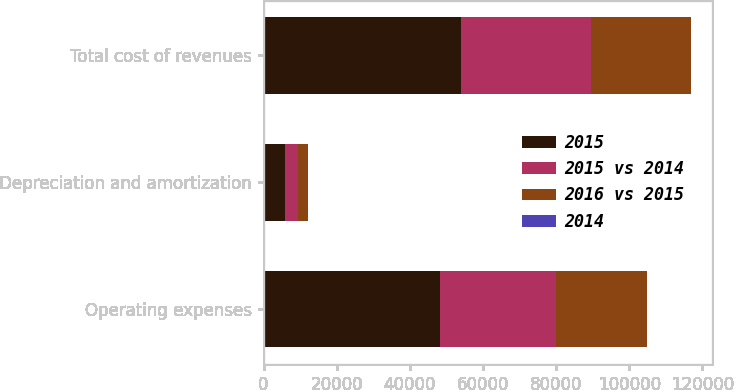<chart> <loc_0><loc_0><loc_500><loc_500><stacked_bar_chart><ecel><fcel>Operating expenses<fcel>Depreciation and amortization<fcel>Total cost of revenues<nl><fcel>2015<fcel>48268<fcel>5798<fcel>54066<nl><fcel>2015 vs 2014<fcel>31790<fcel>3683<fcel>35473<nl><fcel>2016 vs 2015<fcel>24694<fcel>2624<fcel>27318<nl><fcel>2014<fcel>52<fcel>57<fcel>52<nl></chart> 